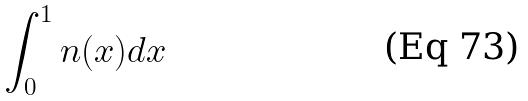<formula> <loc_0><loc_0><loc_500><loc_500>\int _ { 0 } ^ { 1 } n ( x ) d x</formula> 